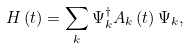<formula> <loc_0><loc_0><loc_500><loc_500>H \left ( t \right ) = \sum _ { k } \Psi _ { k } ^ { \dagger } A _ { k } \left ( t \right ) \Psi _ { k } ,</formula> 